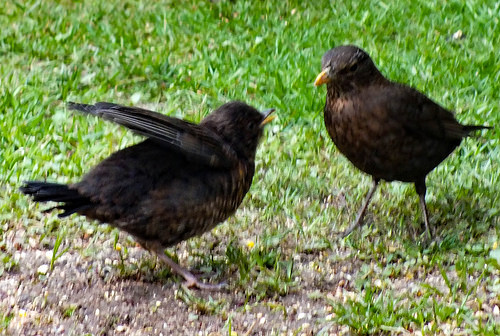<image>
Is there a grass on the bird? No. The grass is not positioned on the bird. They may be near each other, but the grass is not supported by or resting on top of the bird. Is the bird in the grass? Yes. The bird is contained within or inside the grass, showing a containment relationship. Is there a wing next to the wing? No. The wing is not positioned next to the wing. They are located in different areas of the scene. 